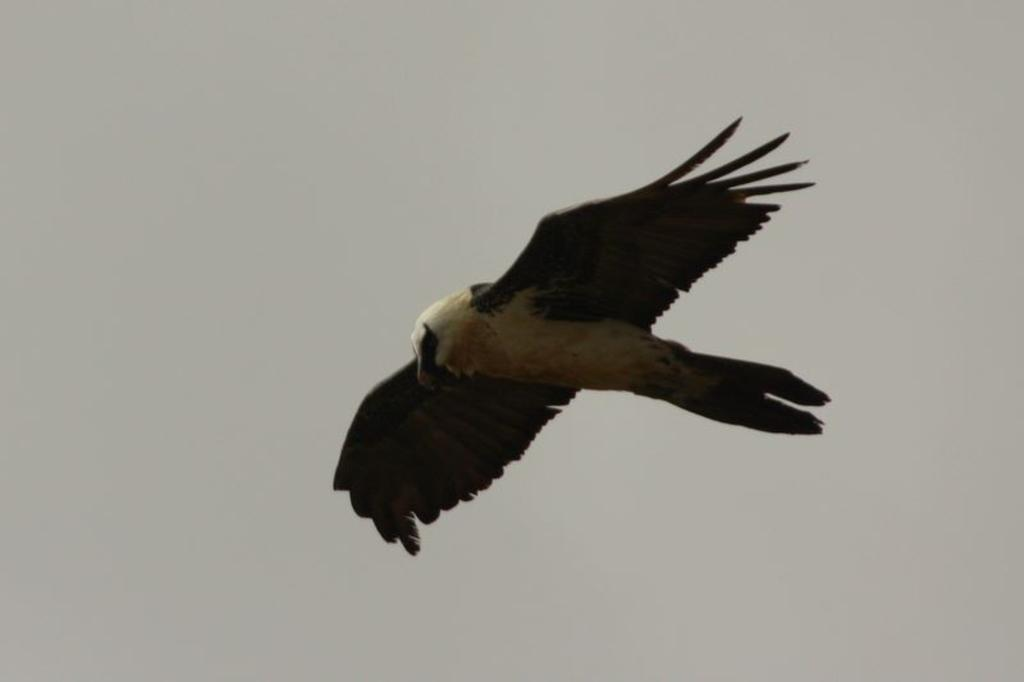What type of animal can be seen in the image? There is a bird in the image. What is the bird doing in the image? The bird is flying in the air. What type of pleasure can be seen being experienced by the bird in the image? There is no indication in the image that the bird is experiencing any specific pleasure. 